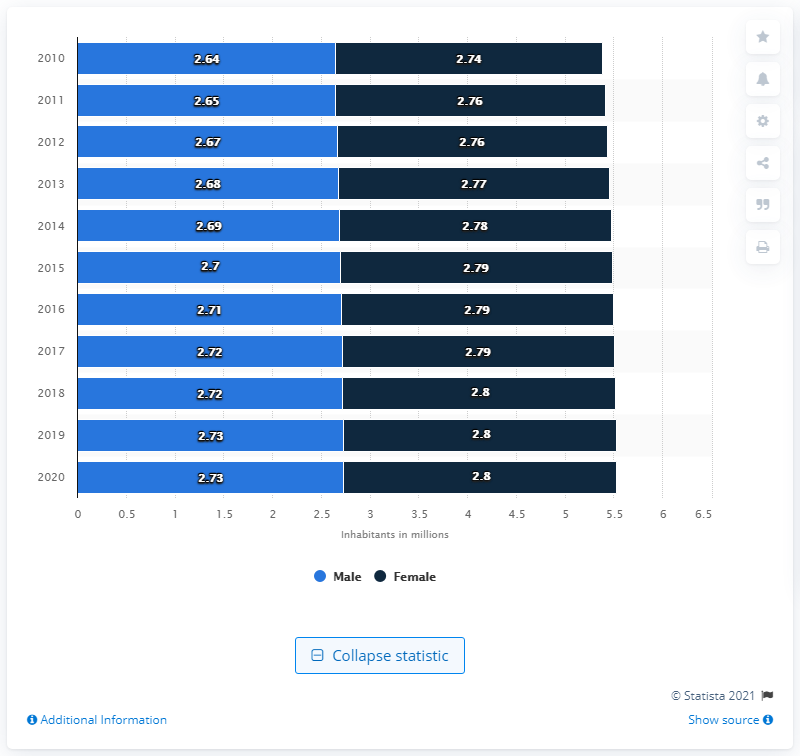List a handful of essential elements in this visual. In 2014, the value for male was 2.69. In 2020, the total value of males and females was 5.53. In 2020, the population of men in Finland was 2.74 million. 